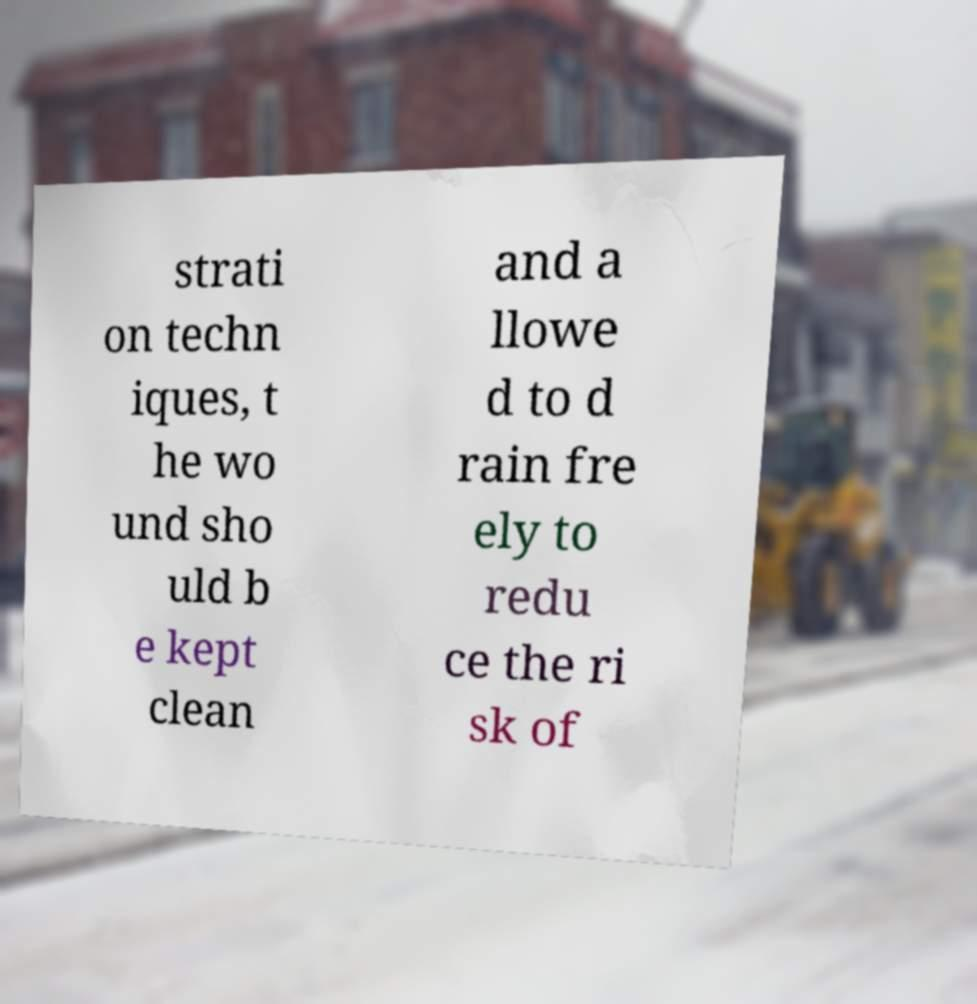Please identify and transcribe the text found in this image. strati on techn iques, t he wo und sho uld b e kept clean and a llowe d to d rain fre ely to redu ce the ri sk of 